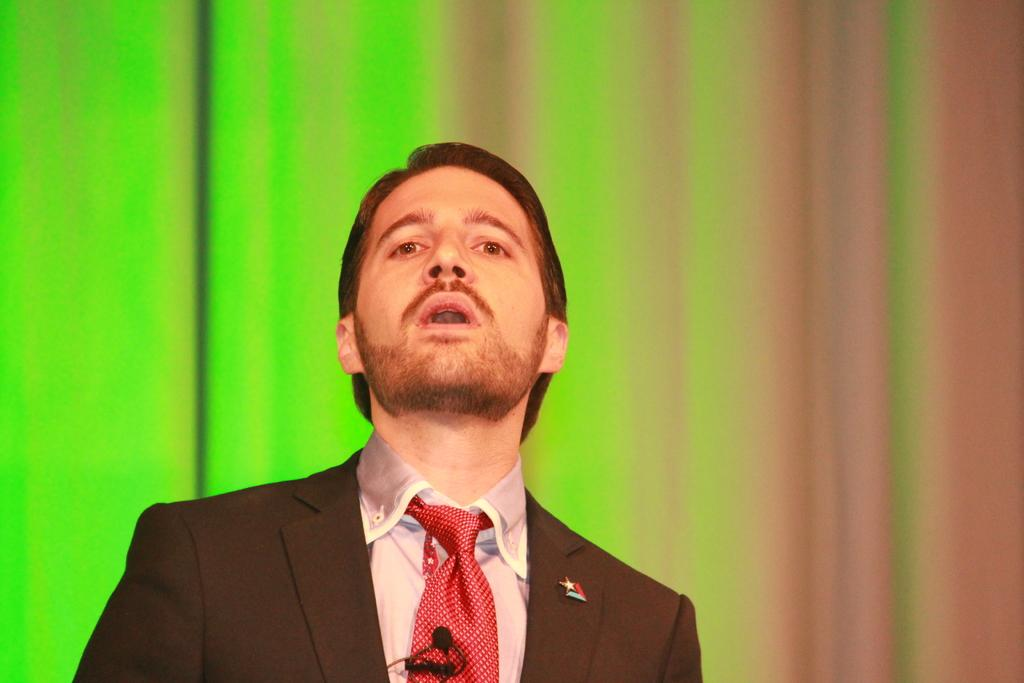What is present in the image? There is a man in the image. What is the man doing in the image? The man is raising his head. What type of clothing is the man wearing? The man is wearing a coat, a shirt, and a tie. What type of bed can be seen in the image? There is no bed present in the image; it features a man raising his head while wearing a coat, a shirt, and a tie. What type of glass is the man holding in the image? There is no glass present in the image. 